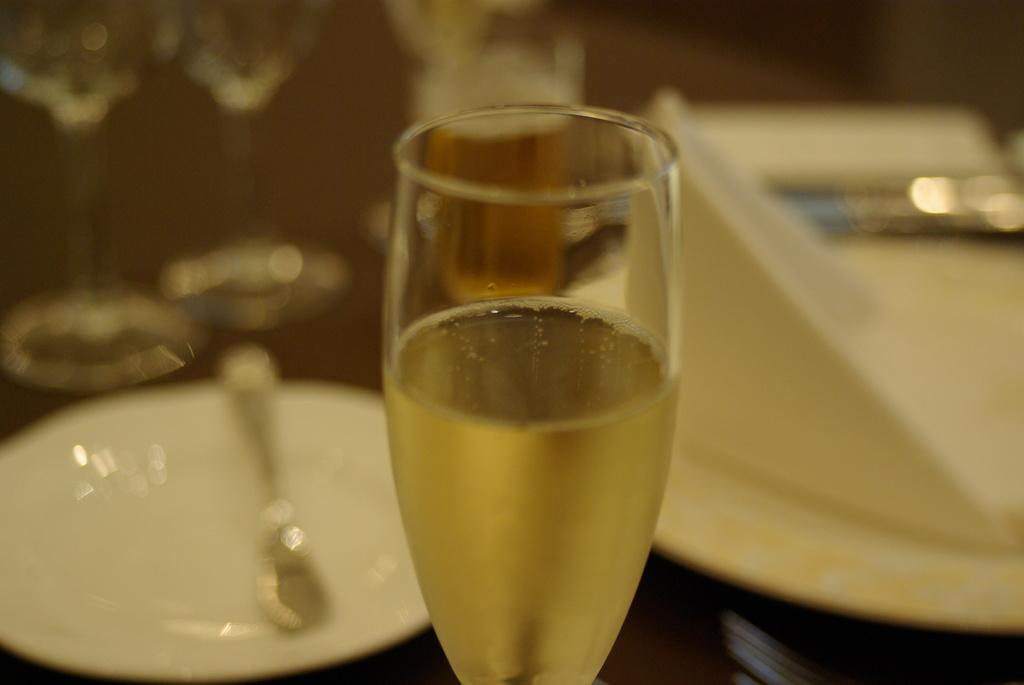What is in the glass that is visible in the image? There is a drink in the glass in the image. What is on the plate that is visible in the image? There is a spoon on the plate in the image. What can be seen in the background of the image? There are glasses and other objects visible in the background of the image. How would you describe the background of the image? The background is blurry. What type of mint is growing on the toe in the image? There is no mint or toe present in the image. 